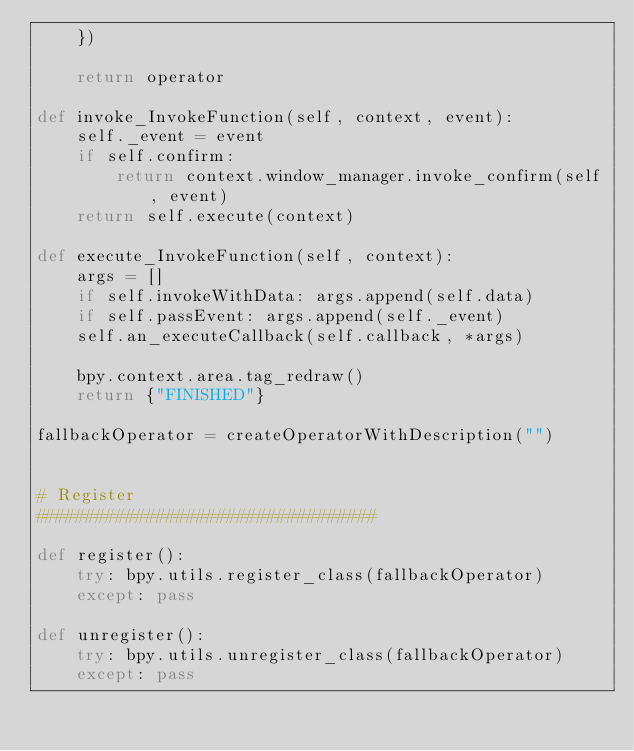Convert code to text. <code><loc_0><loc_0><loc_500><loc_500><_Python_>    })

    return operator

def invoke_InvokeFunction(self, context, event):
    self._event = event
    if self.confirm:
        return context.window_manager.invoke_confirm(self, event)
    return self.execute(context)

def execute_InvokeFunction(self, context):
    args = []
    if self.invokeWithData: args.append(self.data)
    if self.passEvent: args.append(self._event)
    self.an_executeCallback(self.callback, *args)

    bpy.context.area.tag_redraw()
    return {"FINISHED"}

fallbackOperator = createOperatorWithDescription("")


# Register
##################################

def register():
    try: bpy.utils.register_class(fallbackOperator)
    except: pass

def unregister():
    try: bpy.utils.unregister_class(fallbackOperator)
    except: pass
</code> 